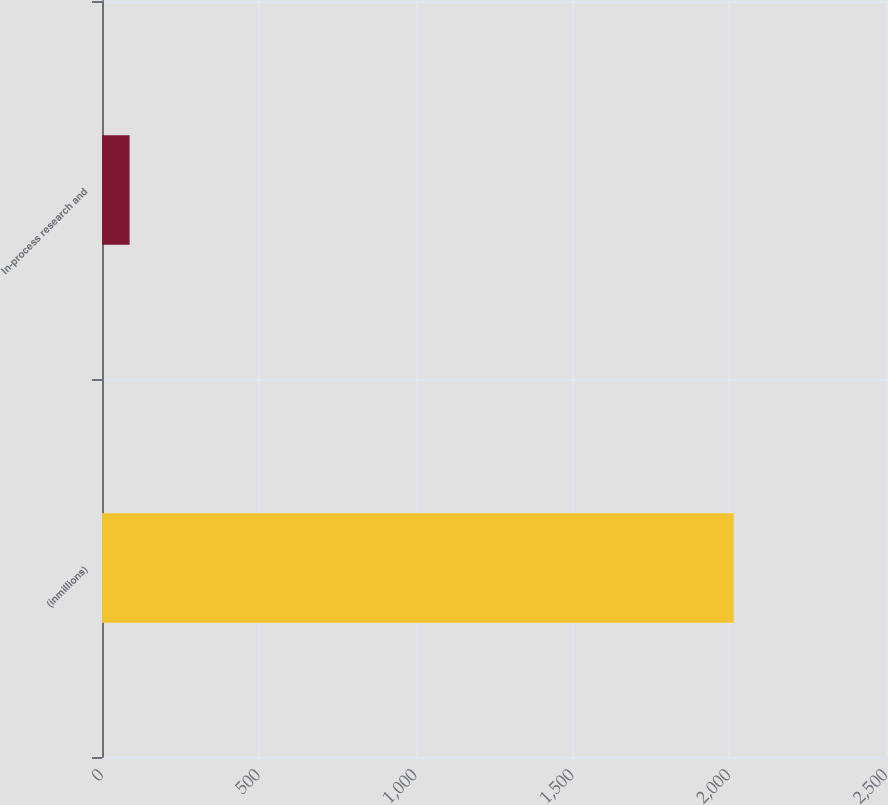Convert chart. <chart><loc_0><loc_0><loc_500><loc_500><bar_chart><fcel>(inmillions)<fcel>In-process research and<nl><fcel>2014<fcel>88<nl></chart> 